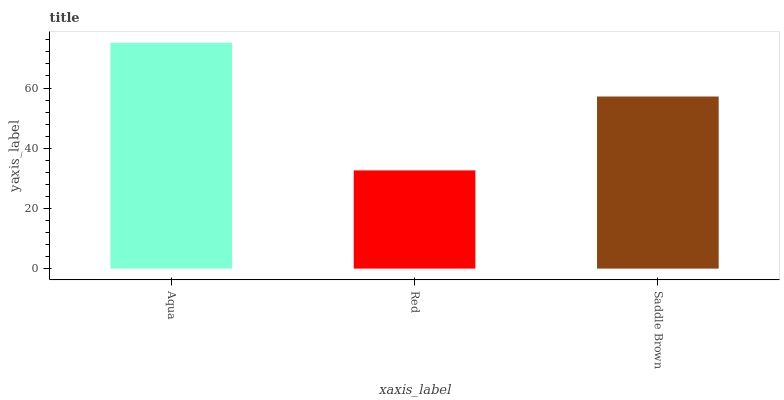Is Red the minimum?
Answer yes or no. Yes. Is Aqua the maximum?
Answer yes or no. Yes. Is Saddle Brown the minimum?
Answer yes or no. No. Is Saddle Brown the maximum?
Answer yes or no. No. Is Saddle Brown greater than Red?
Answer yes or no. Yes. Is Red less than Saddle Brown?
Answer yes or no. Yes. Is Red greater than Saddle Brown?
Answer yes or no. No. Is Saddle Brown less than Red?
Answer yes or no. No. Is Saddle Brown the high median?
Answer yes or no. Yes. Is Saddle Brown the low median?
Answer yes or no. Yes. Is Red the high median?
Answer yes or no. No. Is Red the low median?
Answer yes or no. No. 